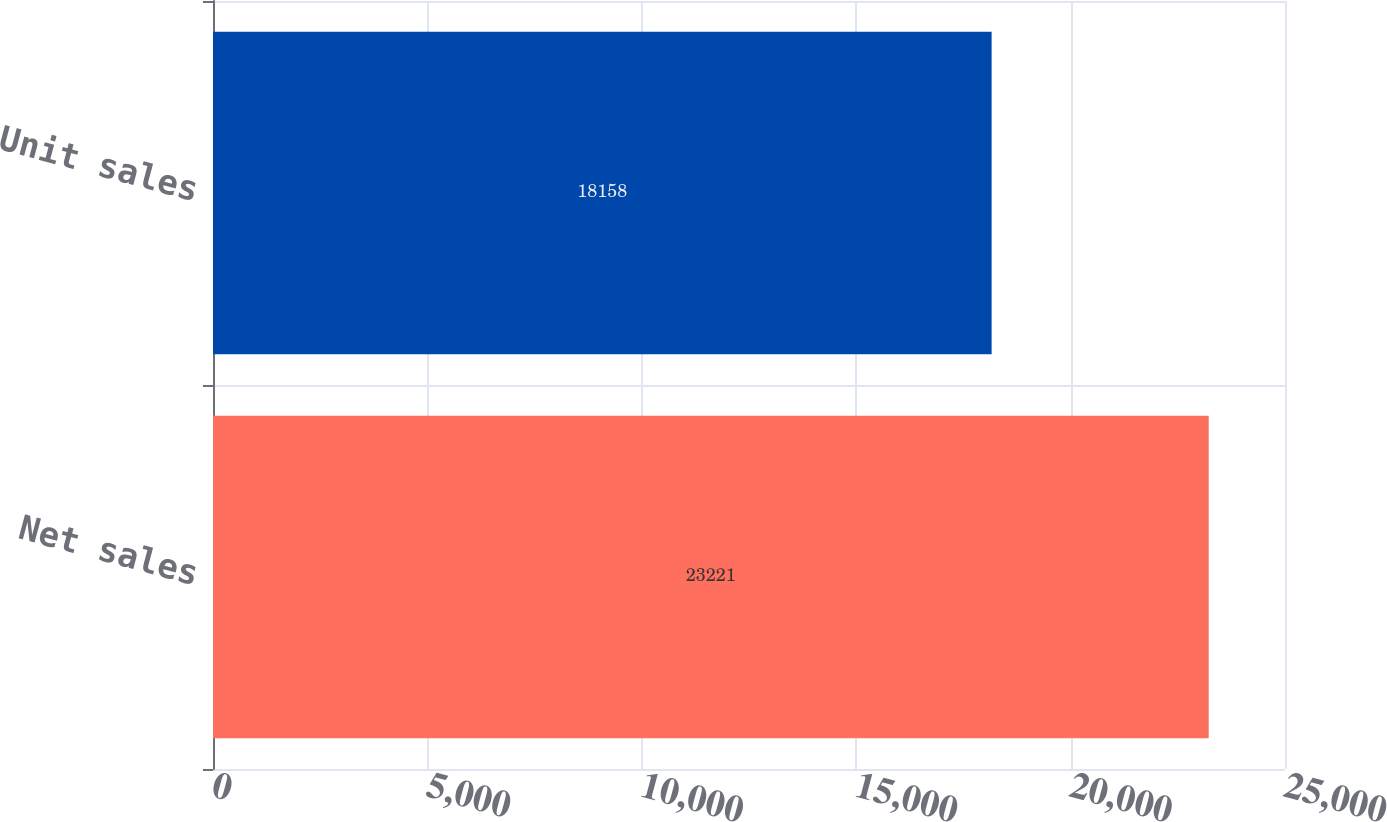Convert chart. <chart><loc_0><loc_0><loc_500><loc_500><bar_chart><fcel>Net sales<fcel>Unit sales<nl><fcel>23221<fcel>18158<nl></chart> 